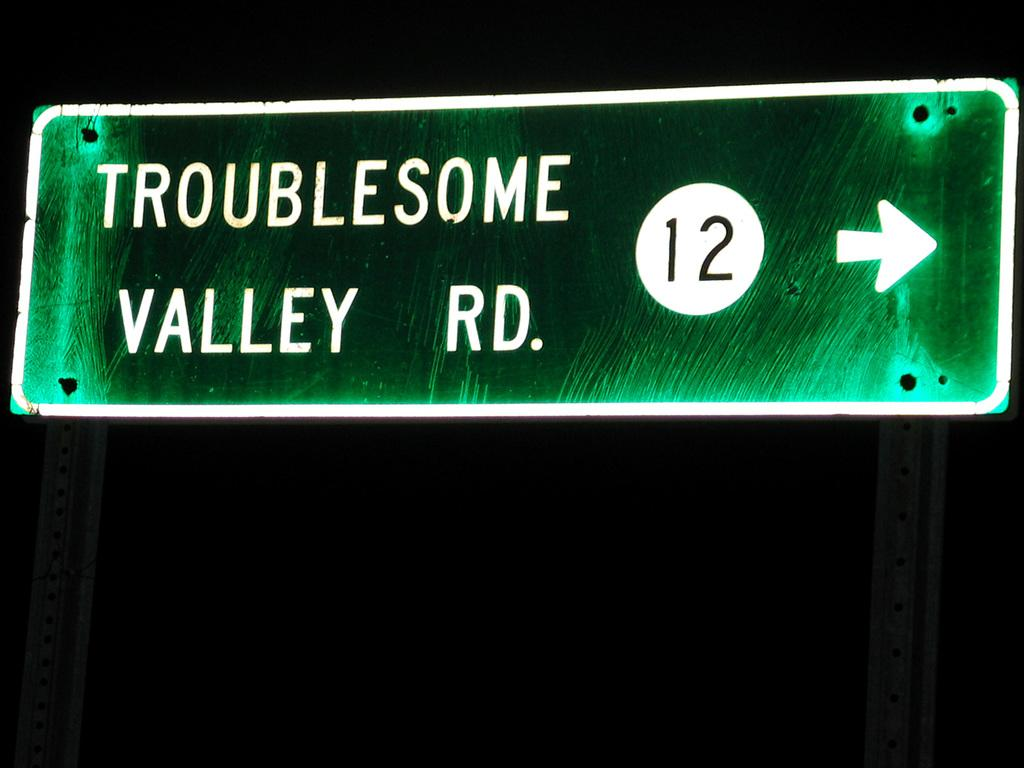What is the main object in the image that is elevated from the ground? There is a board on poles in the image. What is written on the board? There is writing on the board. What type of object is present in the image that provides information or direction? There is a sign in the image. How would you describe the overall lighting in the image? The background of the image is dark. What is the taste of the crib in the image? There is no crib present in the image, and therefore, it cannot have a taste. 